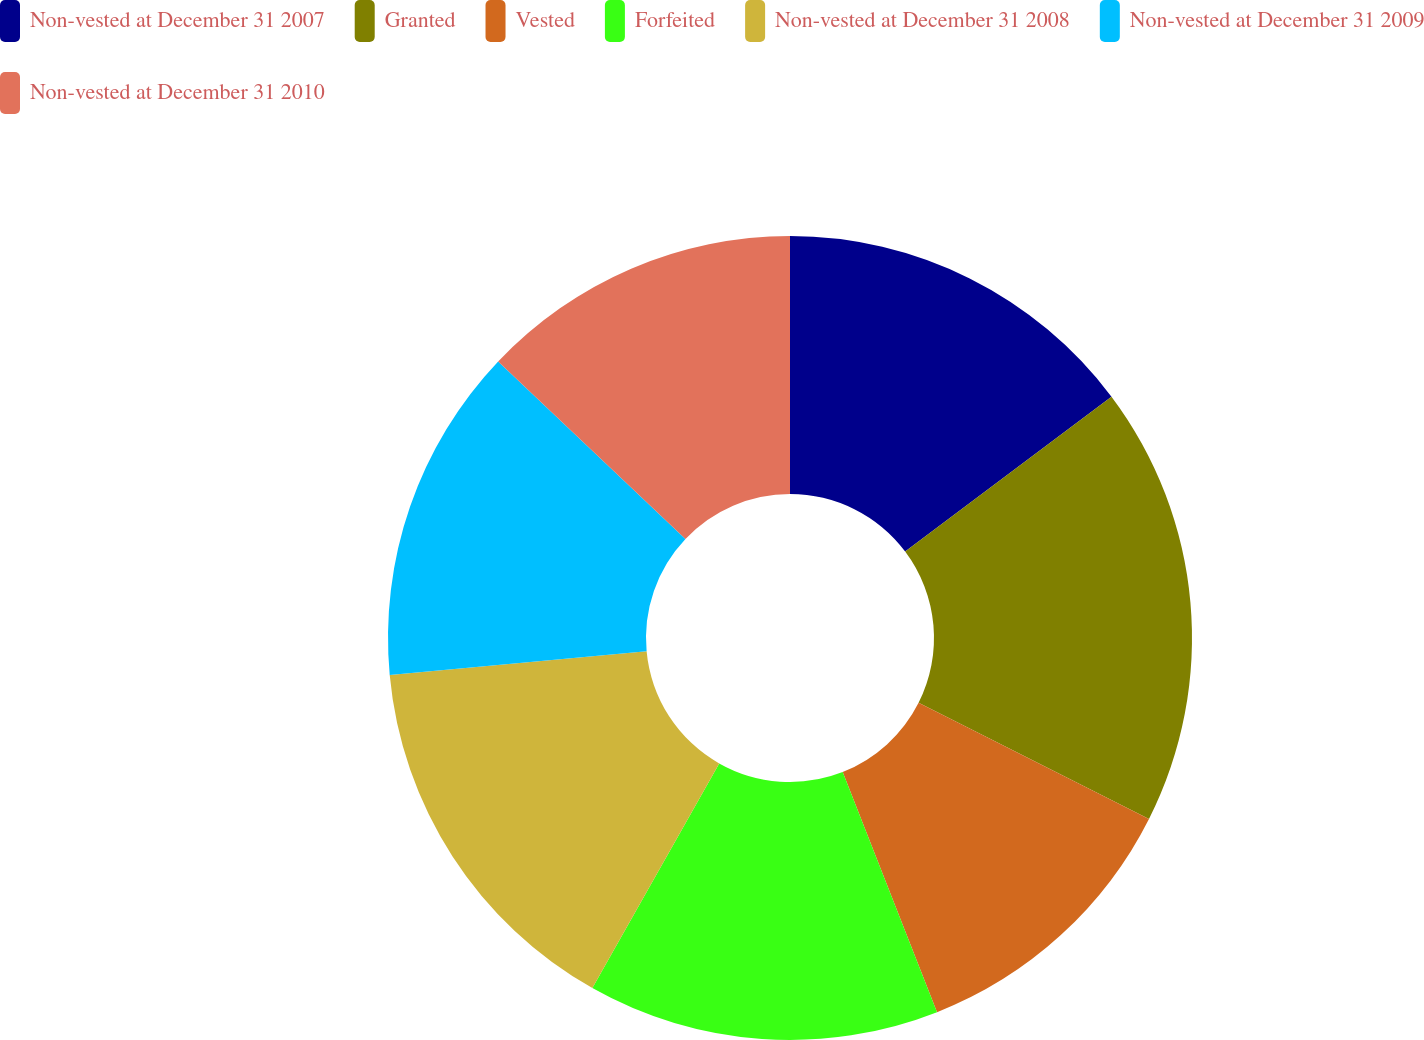<chart> <loc_0><loc_0><loc_500><loc_500><pie_chart><fcel>Non-vested at December 31 2007<fcel>Granted<fcel>Vested<fcel>Forfeited<fcel>Non-vested at December 31 2008<fcel>Non-vested at December 31 2009<fcel>Non-vested at December 31 2010<nl><fcel>14.75%<fcel>17.68%<fcel>11.61%<fcel>14.14%<fcel>15.35%<fcel>13.54%<fcel>12.93%<nl></chart> 